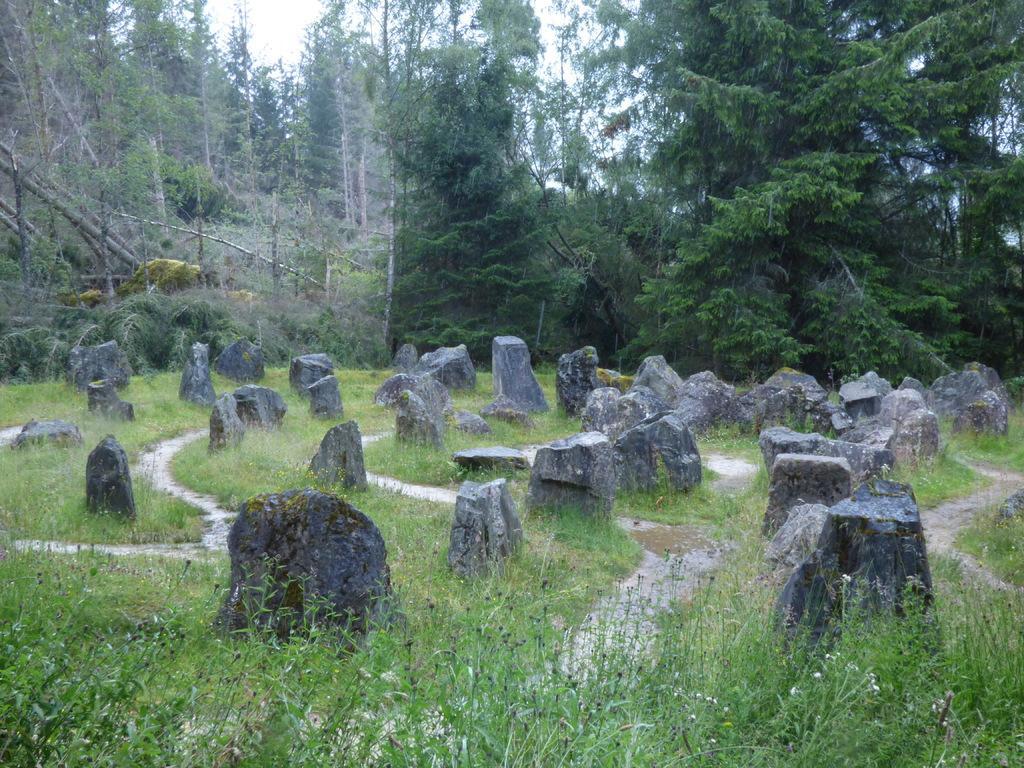Could you give a brief overview of what you see in this image? In this image there are rocks on the ground. Between the rocks there's grass on the ground. Behind the rocks there are trees and tree trunks. At the top there is the sky. 